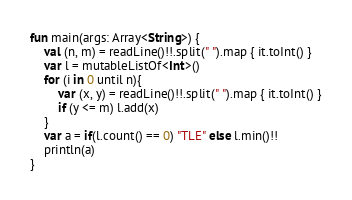Convert code to text. <code><loc_0><loc_0><loc_500><loc_500><_Kotlin_>fun main(args: Array<String>) {
    val (n, m) = readLine()!!.split(" ").map { it.toInt() }
    var l = mutableListOf<Int>()
    for (i in 0 until n){
        var (x, y) = readLine()!!.split(" ").map { it.toInt() }
        if (y <= m) l.add(x)
    }
    var a = if(l.count() == 0) "TLE" else l.min()!!
    println(a)
}</code> 